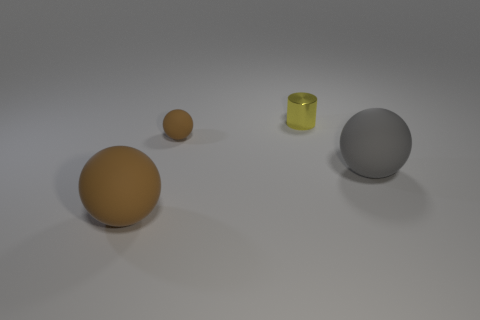Is the material of the small brown sphere the same as the big ball that is behind the big brown thing?
Give a very brief answer. Yes. How many big objects are cylinders or green cylinders?
Your response must be concise. 0. Is the number of small metal objects less than the number of blue metal things?
Your response must be concise. No. Does the brown sphere that is in front of the small brown matte ball have the same size as the brown sphere that is behind the gray sphere?
Ensure brevity in your answer.  No. What number of purple things are either cylinders or balls?
Offer a very short reply. 0. There is another ball that is the same color as the tiny rubber sphere; what size is it?
Offer a terse response. Large. Are there more yellow metallic objects than tiny blue cubes?
Provide a short and direct response. Yes. How many objects are gray matte balls or small objects left of the metal cylinder?
Your answer should be very brief. 2. How many other things are there of the same shape as the tiny yellow shiny thing?
Offer a terse response. 0. Are there fewer gray matte things that are in front of the gray thing than gray matte things that are in front of the small yellow metallic thing?
Offer a very short reply. Yes. 